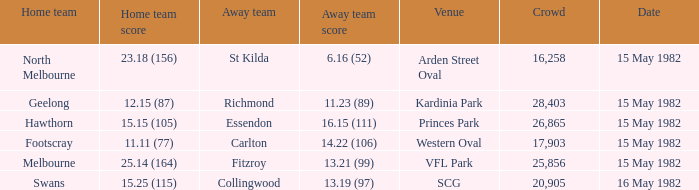Where did Geelong play as the home team? Kardinia Park. 